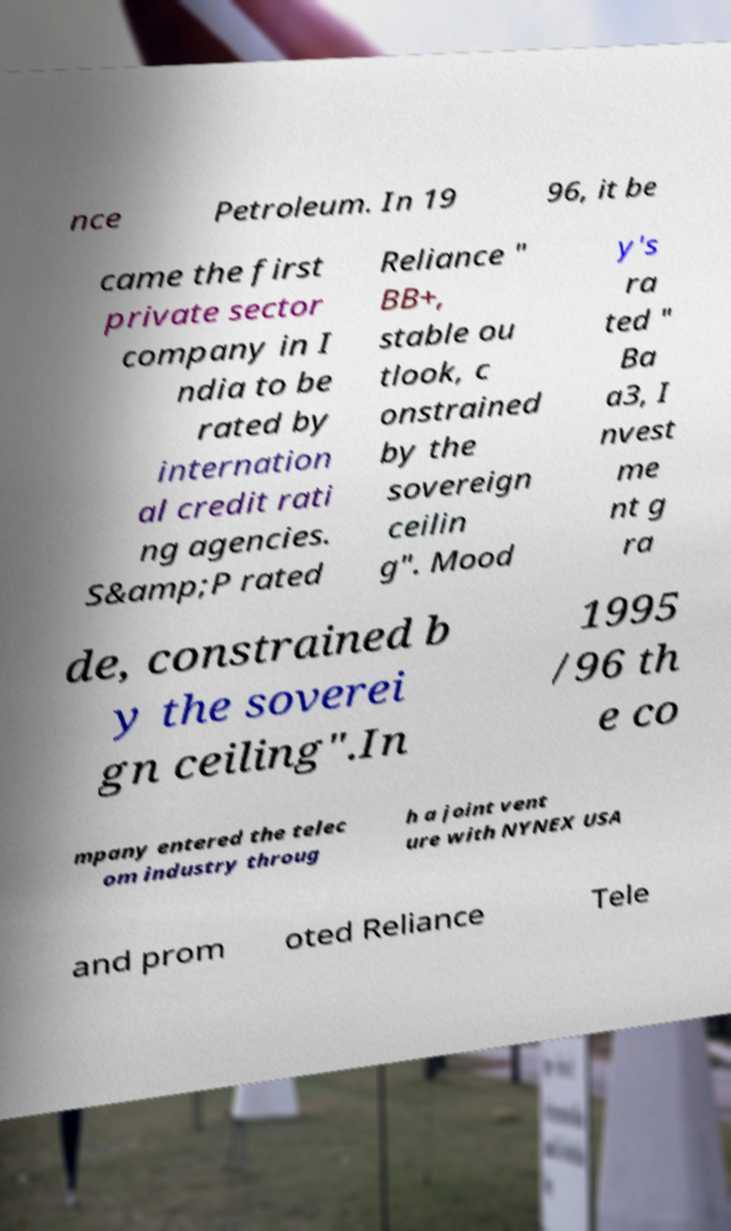Please read and relay the text visible in this image. What does it say? nce Petroleum. In 19 96, it be came the first private sector company in I ndia to be rated by internation al credit rati ng agencies. S&amp;P rated Reliance " BB+, stable ou tlook, c onstrained by the sovereign ceilin g". Mood y's ra ted " Ba a3, I nvest me nt g ra de, constrained b y the soverei gn ceiling".In 1995 /96 th e co mpany entered the telec om industry throug h a joint vent ure with NYNEX USA and prom oted Reliance Tele 